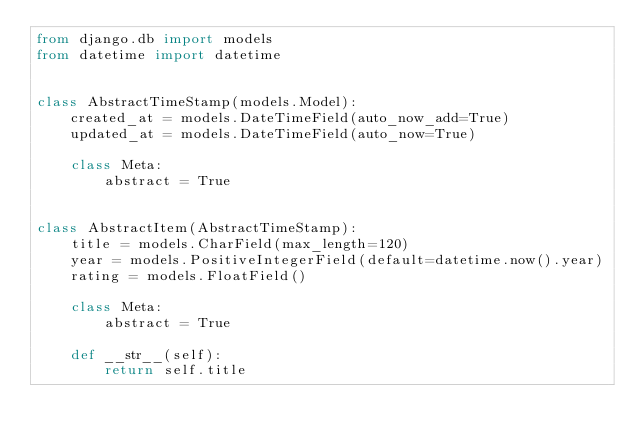<code> <loc_0><loc_0><loc_500><loc_500><_Python_>from django.db import models
from datetime import datetime


class AbstractTimeStamp(models.Model):
    created_at = models.DateTimeField(auto_now_add=True)
    updated_at = models.DateTimeField(auto_now=True)

    class Meta:
        abstract = True


class AbstractItem(AbstractTimeStamp):
    title = models.CharField(max_length=120)
    year = models.PositiveIntegerField(default=datetime.now().year)
    rating = models.FloatField()

    class Meta:
        abstract = True

    def __str__(self):
        return self.title
</code> 